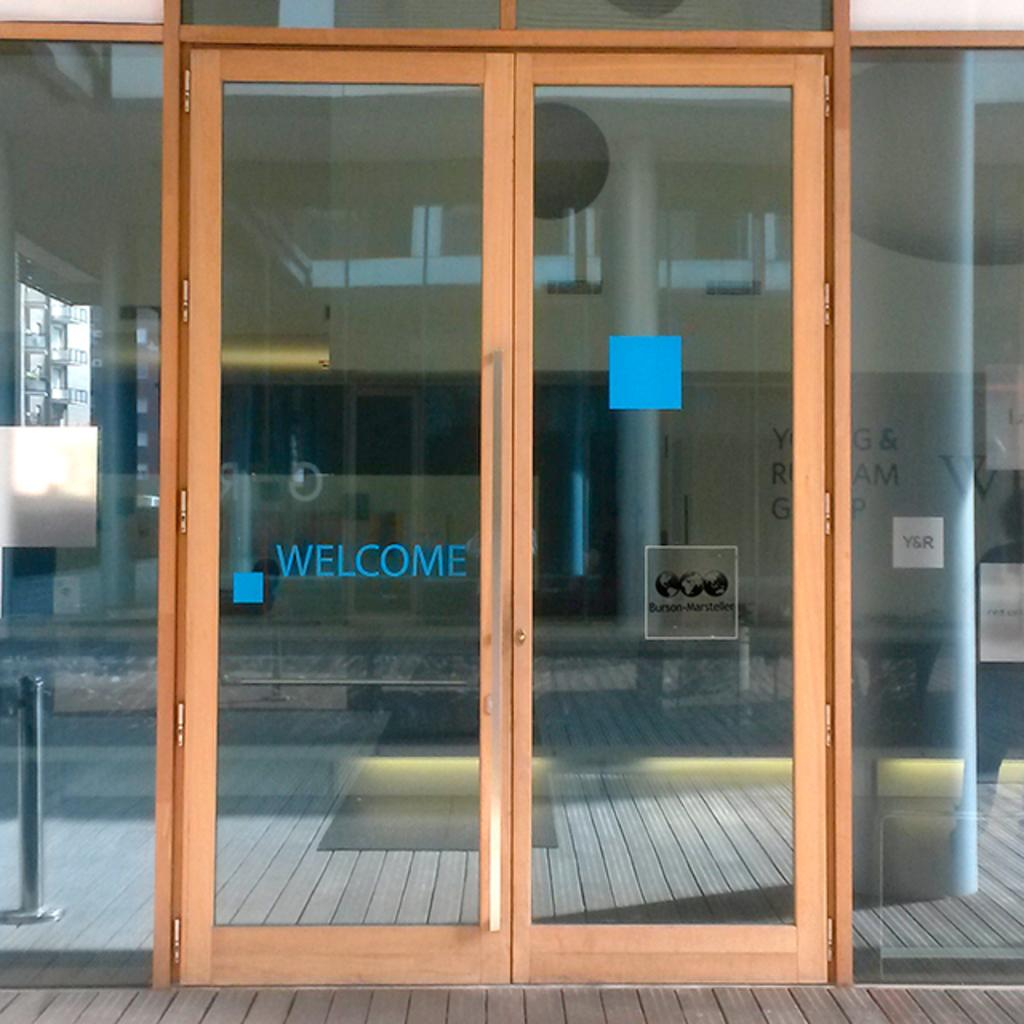What is the main object in the foreground of the image? There is a door in the image. What can be seen behind the door? There is a building visible behind the door. Is there any text present on the building? Yes, there is some text on the building. How many toads are sitting on the boys in the image? There are no toads or boys present in the image. What type of structure is visible behind the door in the image? The provided facts do not specify the type of structure behind the door, only that there is a building visible. 